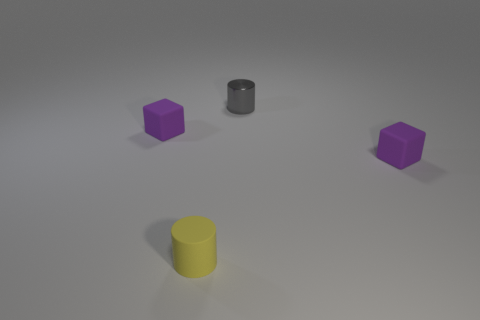What number of small matte objects are behind the small matte block that is on the right side of the tiny gray shiny cylinder?
Keep it short and to the point. 1. Are the tiny block that is to the left of the rubber cylinder and the tiny gray cylinder made of the same material?
Your answer should be compact. No. Do the purple block on the left side of the small yellow cylinder and the tiny purple thing that is on the right side of the small gray object have the same material?
Ensure brevity in your answer.  Yes. Are there more small matte cylinders in front of the tiny gray cylinder than large gray rubber spheres?
Your answer should be compact. Yes. The cylinder that is in front of the tiny purple thing that is right of the small gray metal cylinder is what color?
Your answer should be compact. Yellow. What shape is the yellow thing that is the same size as the metal cylinder?
Your answer should be very brief. Cylinder. Is the number of tiny purple rubber cubes that are in front of the metal cylinder the same as the number of small gray objects?
Offer a very short reply. No. There is a purple object that is to the right of the small purple matte cube that is behind the cube right of the tiny yellow matte thing; what is its material?
Offer a very short reply. Rubber. Is there any other thing that has the same color as the tiny rubber cylinder?
Your response must be concise. No. There is a tiny purple rubber block that is left of the tiny yellow thing that is in front of the tiny gray object; what number of tiny rubber objects are in front of it?
Ensure brevity in your answer.  2. 